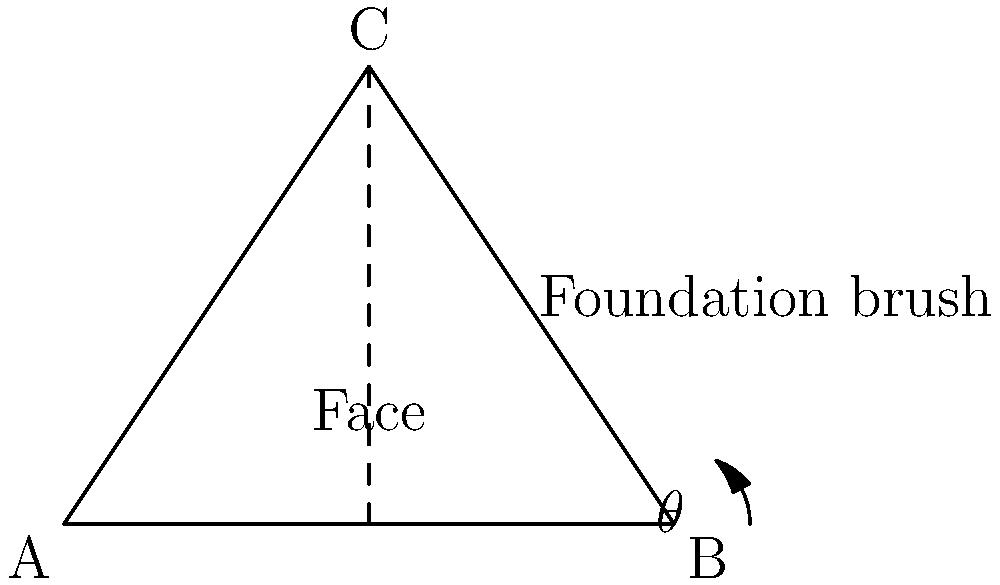A makeup artist is applying foundation to a client's face. The artist knows that the optimal angle for blending foundation to create a seamless finish depends on the contours of the face. If the distance from the cheekbone to the jawline is 4 cm, and the height from the jawline to the highest point of the cheekbone is 3 cm, what is the optimal angle $\theta$ (in degrees) at which the foundation brush should be held for the most effective blending? To find the optimal angle for blending foundation, we need to use trigonometry. Let's approach this step-by-step:

1) In the diagram, we have a right-angled triangle ABC, where:
   - AB represents the distance from the cheekbone to the jawline (4 cm)
   - BC represents the height from the jawline to the highest point of the cheekbone (3 cm)
   - Angle $\theta$ at B is the angle we're looking for

2) To find angle $\theta$, we can use the tangent function:

   $\tan(\theta) = \frac{\text{opposite}}{\text{adjacent}} = \frac{BC}{AB} = \frac{3}{4}$

3) To get $\theta$, we need to take the inverse tangent (arctangent) of this ratio:

   $\theta = \tan^{-1}(\frac{3}{4})$

4) Using a calculator or trigonometric tables:

   $\theta \approx 36.87°$

5) Rounding to the nearest degree:

   $\theta \approx 37°$

Therefore, the optimal angle for holding the foundation brush to achieve a seamless blend is approximately 37 degrees.
Answer: $37°$ 